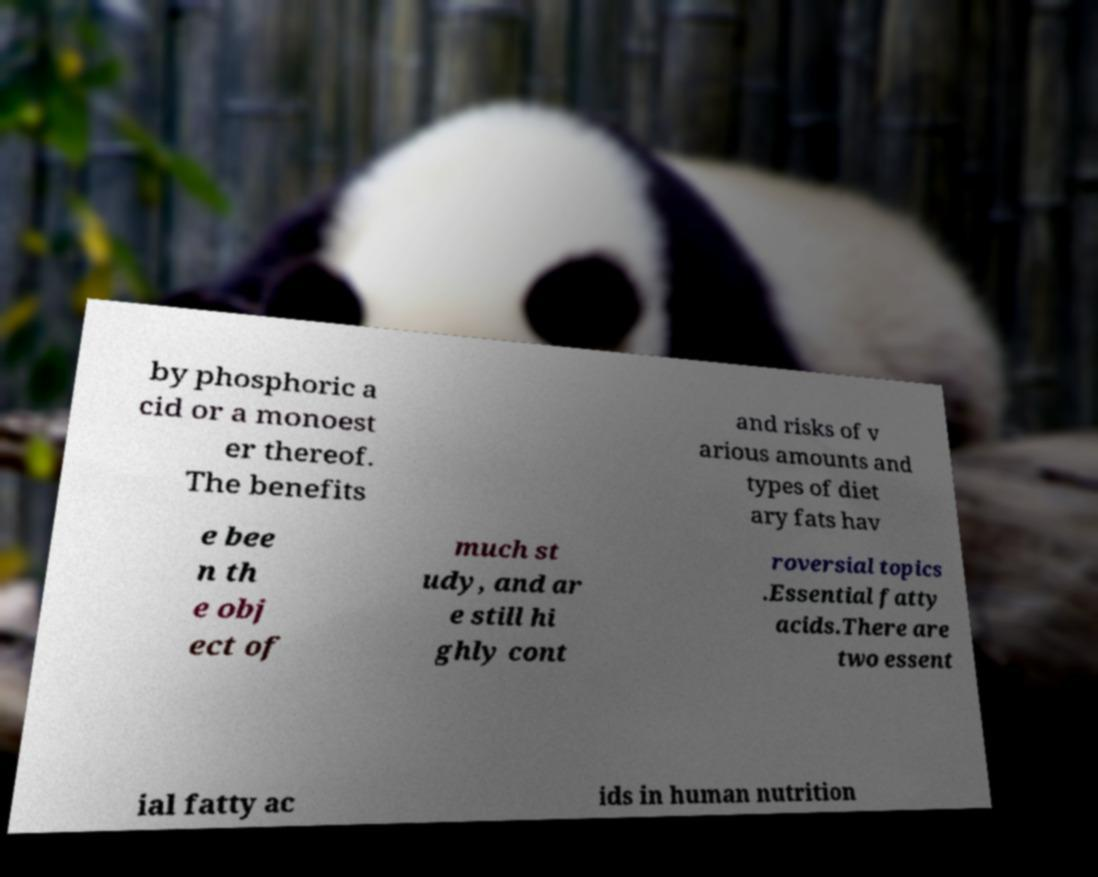Can you accurately transcribe the text from the provided image for me? by phosphoric a cid or a monoest er thereof. The benefits and risks of v arious amounts and types of diet ary fats hav e bee n th e obj ect of much st udy, and ar e still hi ghly cont roversial topics .Essential fatty acids.There are two essent ial fatty ac ids in human nutrition 